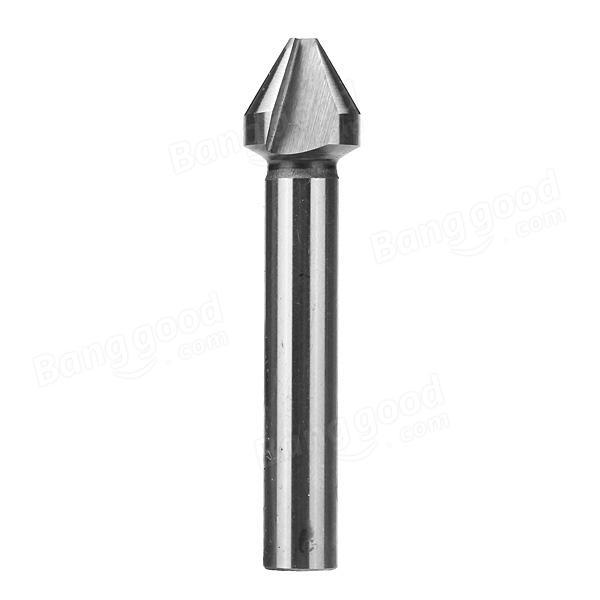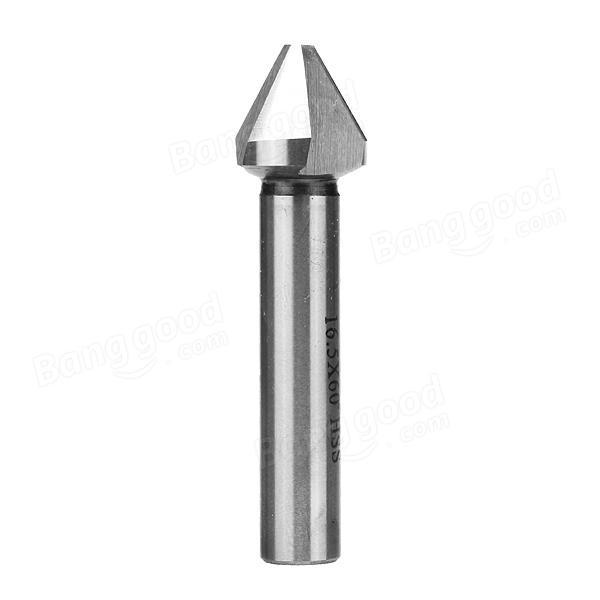The first image is the image on the left, the second image is the image on the right. For the images shown, is this caption "There is a solid metal thing with no visible holes in the right image." true? Answer yes or no. Yes. The first image is the image on the left, the second image is the image on the right. Analyze the images presented: Is the assertion "There is exactly one flute." valid? Answer yes or no. No. 